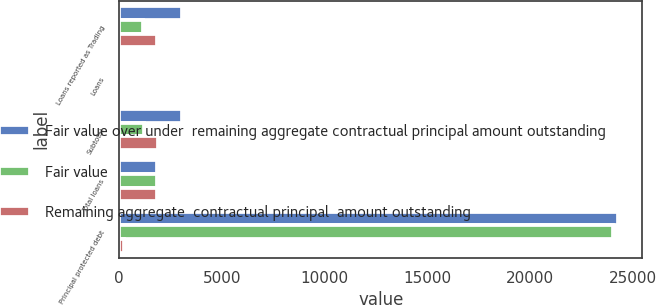Convert chart to OTSL. <chart><loc_0><loc_0><loc_500><loc_500><stacked_bar_chart><ecel><fcel>Loans reported as Trading<fcel>Loans<fcel>Subtotal<fcel>Total loans<fcel>Principal protected debt<nl><fcel>Fair value over under  remaining aggregate contractual principal amount outstanding<fcel>3044<fcel>15<fcel>3070<fcel>1835<fcel>24262<nl><fcel>Fair value<fcel>1176<fcel>5<fcel>1192<fcel>1835<fcel>24033<nl><fcel>Remaining aggregate  contractual principal  amount outstanding<fcel>1868<fcel>10<fcel>1878<fcel>1835<fcel>229<nl></chart> 